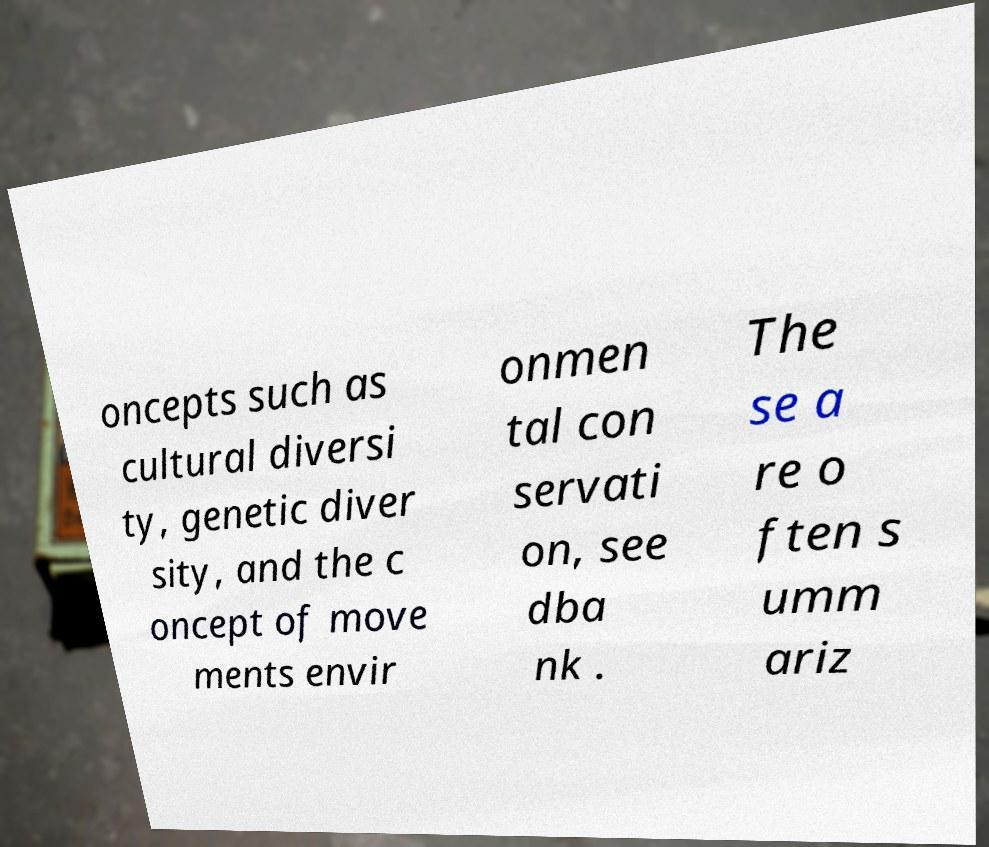There's text embedded in this image that I need extracted. Can you transcribe it verbatim? oncepts such as cultural diversi ty, genetic diver sity, and the c oncept of move ments envir onmen tal con servati on, see dba nk . The se a re o ften s umm ariz 